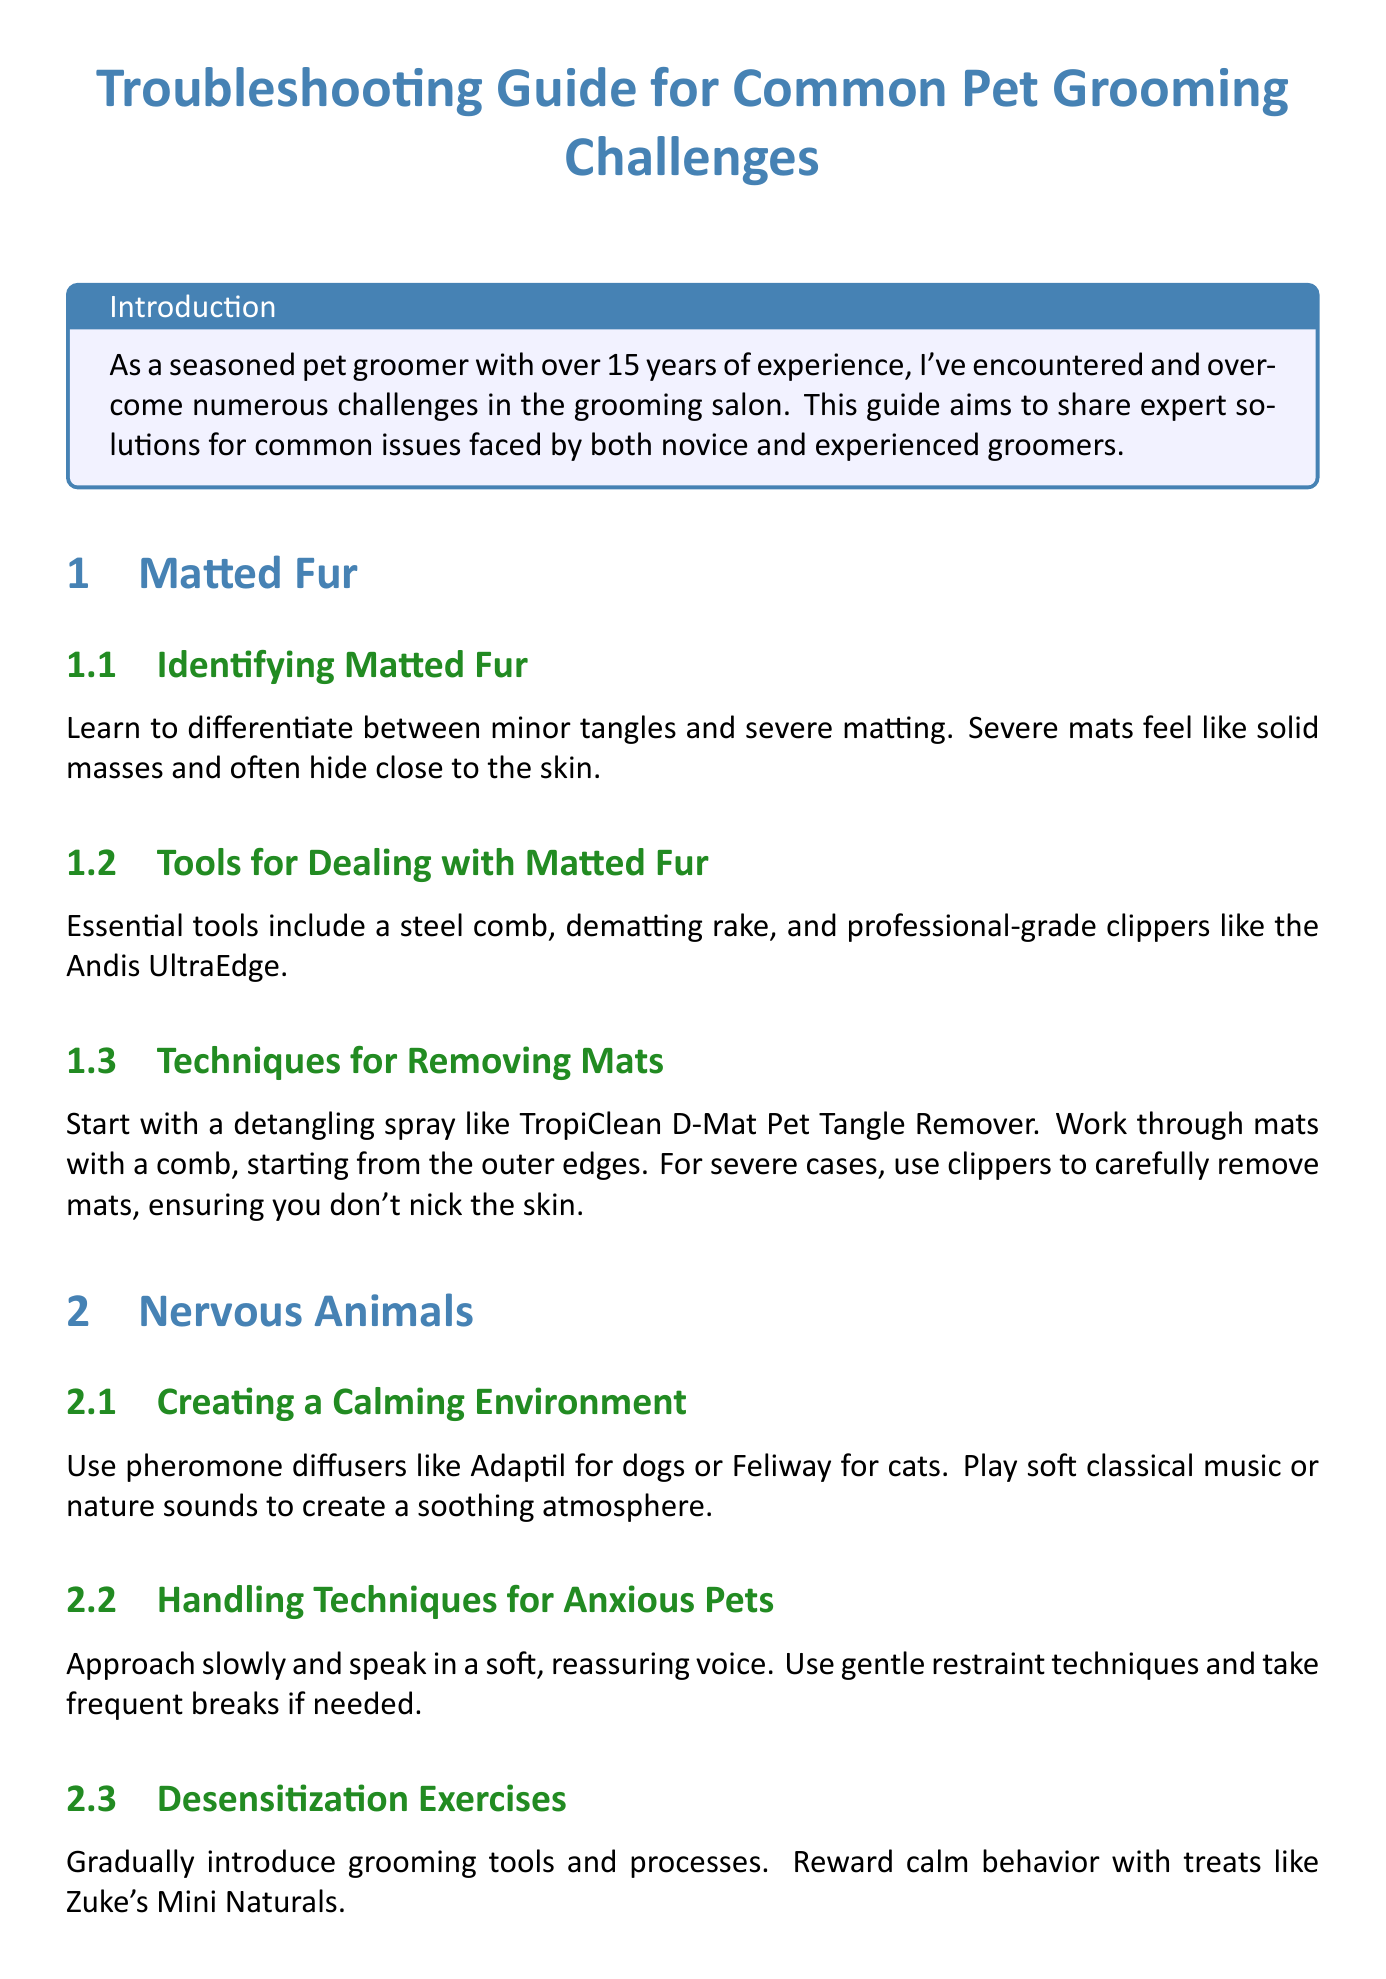What are two essential tools for dealing with matted fur? The document lists essential tools for matted fur under the section "Tools for Dealing with Matted Fur", which includes a steel comb and dematting rake.
Answer: steel comb, dematting rake What is recommended for creating a calming environment for nervous animals? The document suggests using pheromone diffusers and playing soft music to create a soothing atmosphere in the "Creating a Calming Environment" subsection.
Answer: pheromone diffusers, soft music What should you do if a pet shows signs of aggression? The "Safety Measures" subsection advises to use proper restraints and keep muzzles on hand for emergency use when dealing with aggressive pets.
Answer: use proper restraints, keep muzzles on hand When should you refer to a veterinarian for skin issues? The document specifies that certain skin issues may require medical attention and should be recognized when they are beyond grooming solutions in the "When to Refer to a Veterinarian" subsection.
Answer: beyond grooming solutions What product is suggested for desensitization exercises with anxious pets? The document recommends rewarding calm behavior with treats like Zuke's Mini Naturals as part of desensitization exercises for anxious pets.
Answer: Zuke's Mini Naturals What does the document recommend for trimming dark nails? The "Dealing with Dark Nails" subsection advises using a high-quality nail clipper and trimming in small increments to avoid cutting the quick.
Answer: trim in small increments How long has the author been a pet groomer? The introduction mentions that the author has over 15 years of experience as a pet groomer.
Answer: over 15 years What is the key to managing challenging grooming situations? The conclusion emphasizes that patience is key in effectively managing even the most challenging grooming situations.
Answer: patience 